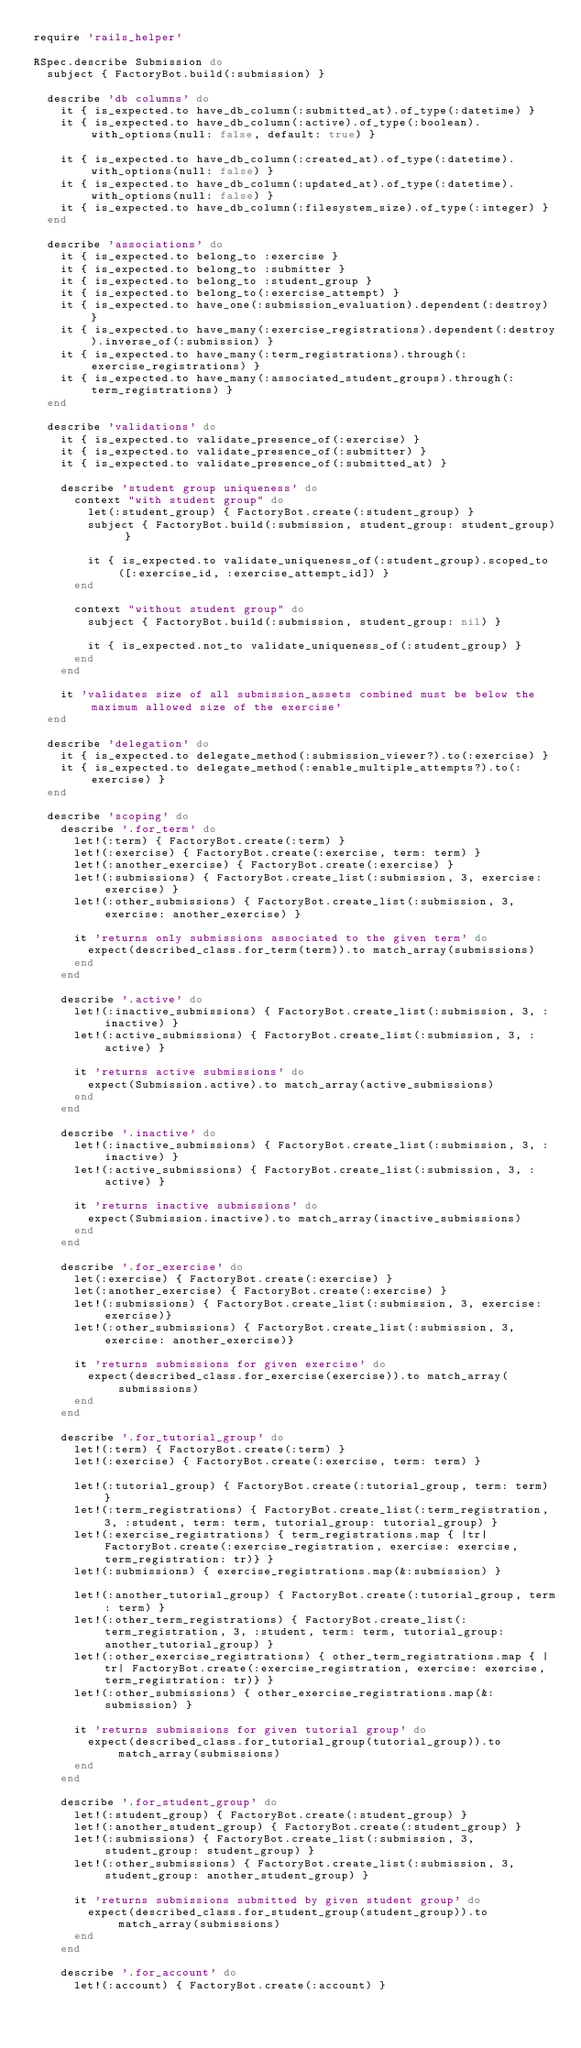Convert code to text. <code><loc_0><loc_0><loc_500><loc_500><_Ruby_>require 'rails_helper'

RSpec.describe Submission do
  subject { FactoryBot.build(:submission) }

  describe 'db columns' do
    it { is_expected.to have_db_column(:submitted_at).of_type(:datetime) }
    it { is_expected.to have_db_column(:active).of_type(:boolean).with_options(null: false, default: true) }

    it { is_expected.to have_db_column(:created_at).of_type(:datetime).with_options(null: false) }
    it { is_expected.to have_db_column(:updated_at).of_type(:datetime).with_options(null: false) }
    it { is_expected.to have_db_column(:filesystem_size).of_type(:integer) }
  end

  describe 'associations' do
    it { is_expected.to belong_to :exercise }
    it { is_expected.to belong_to :submitter }
    it { is_expected.to belong_to :student_group }
    it { is_expected.to belong_to(:exercise_attempt) }
    it { is_expected.to have_one(:submission_evaluation).dependent(:destroy) }
    it { is_expected.to have_many(:exercise_registrations).dependent(:destroy).inverse_of(:submission) }
    it { is_expected.to have_many(:term_registrations).through(:exercise_registrations) }
    it { is_expected.to have_many(:associated_student_groups).through(:term_registrations) }
  end

  describe 'validations' do
    it { is_expected.to validate_presence_of(:exercise) }
    it { is_expected.to validate_presence_of(:submitter) }
    it { is_expected.to validate_presence_of(:submitted_at) }

    describe 'student group uniqueness' do
      context "with student group" do
        let(:student_group) { FactoryBot.create(:student_group) }
        subject { FactoryBot.build(:submission, student_group: student_group) }

        it { is_expected.to validate_uniqueness_of(:student_group).scoped_to([:exercise_id, :exercise_attempt_id]) }
      end

      context "without student group" do
        subject { FactoryBot.build(:submission, student_group: nil) }

        it { is_expected.not_to validate_uniqueness_of(:student_group) }
      end
    end

    it 'validates size of all submission_assets combined must be below the maximum allowed size of the exercise'
  end

  describe 'delegation' do
    it { is_expected.to delegate_method(:submission_viewer?).to(:exercise) }
    it { is_expected.to delegate_method(:enable_multiple_attempts?).to(:exercise) }
  end

  describe 'scoping' do
    describe '.for_term' do
      let!(:term) { FactoryBot.create(:term) }
      let!(:exercise) { FactoryBot.create(:exercise, term: term) }
      let!(:another_exercise) { FactoryBot.create(:exercise) }
      let!(:submissions) { FactoryBot.create_list(:submission, 3, exercise: exercise) }
      let!(:other_submissions) { FactoryBot.create_list(:submission, 3, exercise: another_exercise) }

      it 'returns only submissions associated to the given term' do
        expect(described_class.for_term(term)).to match_array(submissions)
      end
    end

    describe '.active' do
      let!(:inactive_submissions) { FactoryBot.create_list(:submission, 3, :inactive) }
      let!(:active_submissions) { FactoryBot.create_list(:submission, 3, :active) }

      it 'returns active submissions' do
        expect(Submission.active).to match_array(active_submissions)
      end
    end

    describe '.inactive' do
      let!(:inactive_submissions) { FactoryBot.create_list(:submission, 3, :inactive) }
      let!(:active_submissions) { FactoryBot.create_list(:submission, 3, :active) }

      it 'returns inactive submissions' do
        expect(Submission.inactive).to match_array(inactive_submissions)
      end
    end

    describe '.for_exercise' do
      let(:exercise) { FactoryBot.create(:exercise) }
      let(:another_exercise) { FactoryBot.create(:exercise) }
      let!(:submissions) { FactoryBot.create_list(:submission, 3, exercise: exercise)}
      let!(:other_submissions) { FactoryBot.create_list(:submission, 3, exercise: another_exercise)}

      it 'returns submissions for given exercise' do
        expect(described_class.for_exercise(exercise)).to match_array(submissions)
      end
    end

    describe '.for_tutorial_group' do
      let!(:term) { FactoryBot.create(:term) }
      let!(:exercise) { FactoryBot.create(:exercise, term: term) }

      let!(:tutorial_group) { FactoryBot.create(:tutorial_group, term: term) }
      let!(:term_registrations) { FactoryBot.create_list(:term_registration, 3, :student, term: term, tutorial_group: tutorial_group) }
      let!(:exercise_registrations) { term_registrations.map { |tr| FactoryBot.create(:exercise_registration, exercise: exercise, term_registration: tr)} }
      let!(:submissions) { exercise_registrations.map(&:submission) }

      let!(:another_tutorial_group) { FactoryBot.create(:tutorial_group, term: term) }
      let!(:other_term_registrations) { FactoryBot.create_list(:term_registration, 3, :student, term: term, tutorial_group: another_tutorial_group) }
      let!(:other_exercise_registrations) { other_term_registrations.map { |tr| FactoryBot.create(:exercise_registration, exercise: exercise, term_registration: tr)} }
      let!(:other_submissions) { other_exercise_registrations.map(&:submission) }

      it 'returns submissions for given tutorial group' do
        expect(described_class.for_tutorial_group(tutorial_group)).to match_array(submissions)
      end
    end

    describe '.for_student_group' do
      let!(:student_group) { FactoryBot.create(:student_group) }
      let!(:another_student_group) { FactoryBot.create(:student_group) }
      let!(:submissions) { FactoryBot.create_list(:submission, 3, student_group: student_group) }
      let!(:other_submissions) { FactoryBot.create_list(:submission, 3, student_group: another_student_group) }

      it 'returns submissions submitted by given student group' do
        expect(described_class.for_student_group(student_group)).to match_array(submissions)
      end
    end

    describe '.for_account' do
      let!(:account) { FactoryBot.create(:account) }</code> 